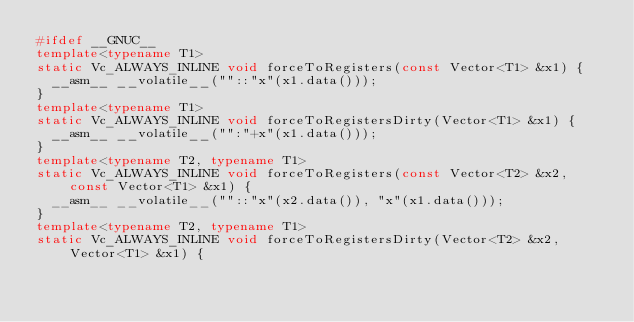Convert code to text. <code><loc_0><loc_0><loc_500><loc_500><_C++_>#ifdef __GNUC__
template<typename T1>
static Vc_ALWAYS_INLINE void forceToRegisters(const Vector<T1> &x1) {
  __asm__ __volatile__(""::"x"(x1.data()));
}
template<typename T1>
static Vc_ALWAYS_INLINE void forceToRegistersDirty(Vector<T1> &x1) {
  __asm__ __volatile__("":"+x"(x1.data()));
}
template<typename T2, typename T1>
static Vc_ALWAYS_INLINE void forceToRegisters(const Vector<T2> &x2, const Vector<T1> &x1) {
  __asm__ __volatile__(""::"x"(x2.data()), "x"(x1.data()));
}
template<typename T2, typename T1>
static Vc_ALWAYS_INLINE void forceToRegistersDirty(Vector<T2> &x2, Vector<T1> &x1) {</code> 